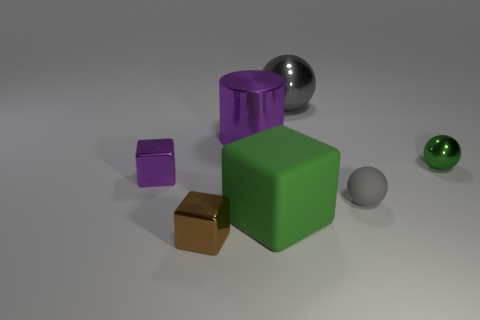The metallic thing that is the same color as the small matte ball is what size?
Your response must be concise. Large. What is the shape of the big metallic object that is in front of the ball behind the big purple cylinder?
Give a very brief answer. Cylinder. How many other objects are the same shape as the tiny green metal thing?
Offer a very short reply. 2. There is a shiny sphere in front of the large metallic thing in front of the big metallic sphere; what is its size?
Your answer should be very brief. Small. Is there a big yellow metal sphere?
Your response must be concise. No. There is a sphere that is in front of the small green thing; how many big spheres are on the right side of it?
Your response must be concise. 0. There is a rubber thing in front of the small gray matte thing; what is its shape?
Provide a succinct answer. Cube. There is a tiny thing that is in front of the cube that is to the right of the cube that is in front of the green block; what is it made of?
Make the answer very short. Metal. What number of other objects are the same size as the gray matte sphere?
Offer a very short reply. 3. What is the material of the small gray object that is the same shape as the tiny green object?
Offer a very short reply. Rubber. 